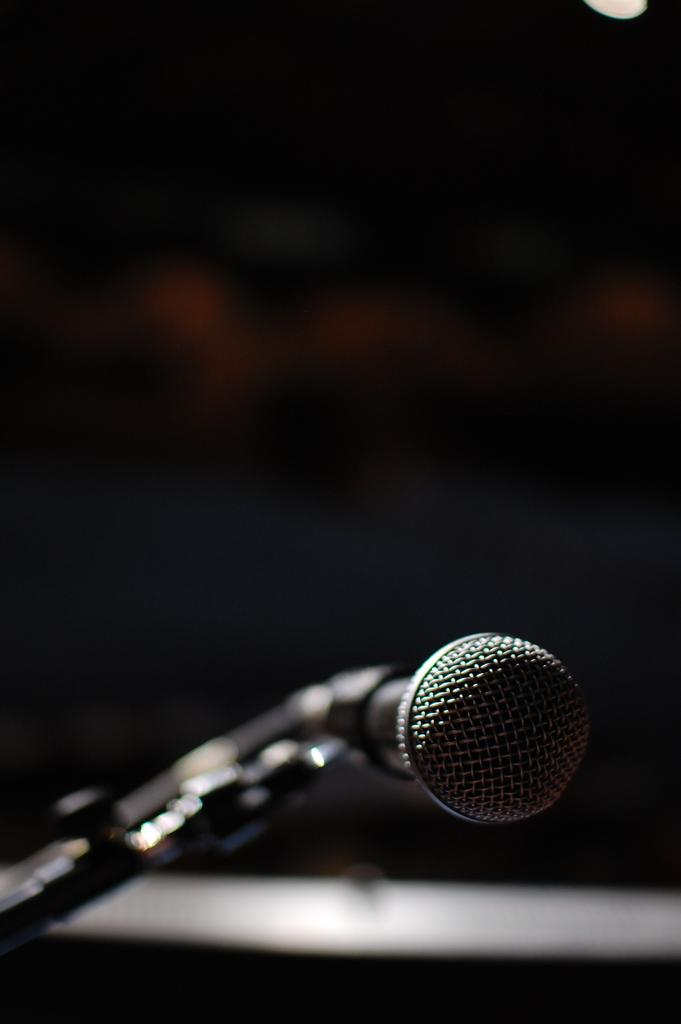What is the main subject of the image? The main subject of the image is a mile. How is the mile positioned in the image? The mile is attached to a metal stand. What is the color of the background in the image? The background of the image is black. Can you tell me how many people are walking on the trail in the image? There is no trail or people walking in the image; it features a mile attached to a metal stand with a black background. What type of fictional character can be seen interacting with the mile in the image? There is no fictional character present in the image; it only features a mile attached to a metal stand with a black background. 